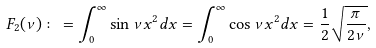Convert formula to latex. <formula><loc_0><loc_0><loc_500><loc_500>F _ { 2 } ( \nu ) \colon = \int _ { 0 } ^ { \infty } \sin \nu x ^ { 2 } d x = \int _ { 0 } ^ { \infty } \cos \nu x ^ { 2 } d x = \frac { 1 } { 2 } \sqrt { \frac { \pi } { 2 \nu } } ,</formula> 